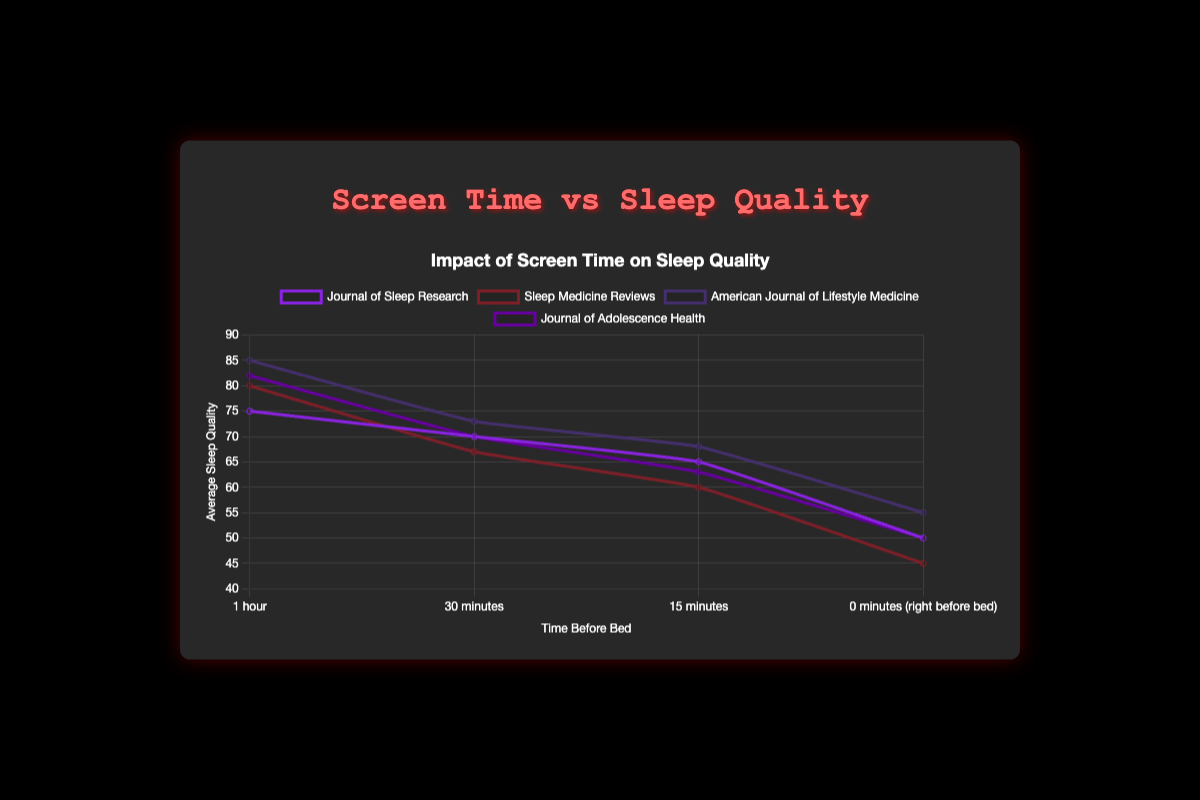What is the general trend of sleep quality as screen time increases right before bed? By looking at the data, we notice a negative trend where sleep quality decreases as screen time increases right before bed. Specifically, from 1 hour to 0 minutes (right before bed), the sleep quality generally declines.
Answer: Sleep quality decreases Which dataset shows the highest average sleep quality for screen time of 1 hour before bed? Looking at the line chart, "American Journal of Lifestyle Medicine" shows the highest average sleep quality for screen time of 1 hour before bed, which is 85.
Answer: American Journal of Lifestyle Medicine Compare the sleep quality for screen time at "15 minutes" and "0 minutes (right before bed)" in the "Journal of Adolescence Health" dataset. For the "Journal of Adolescence Health" dataset, the sleep quality is 63 at "15 minutes" and 50 at "0 minutes (right before bed)". Thus, the sleep quality is higher at "15 minutes" before bed.
Answer: 63 vs. 50 By how much does the sleep quality decrease on average when comparing screen time of 1 hour to “0 minutes (right before bed)” across all sources? For each source, calcualte the decrease in sleep quality: Journal of Sleep Research (75 - 50 = 25%), Sleep Medicine Reviews (80 - 45 = 35%), American Journal of Lifestyle Medicine (85 - 55 = 30%), Journal of Adolescence Health (82 - 50 = 32%). Averaging these: (25% + 35% + 30% + 32%)/4 = 30.5%.
Answer: 30.5% Which color line represents the "Sleep Medicine Reviews" average sleep quality? In the chart, each dataset is represented by a different color line. To identify "Sleep Medicine Reviews", we must reference the legend.
Answer: Varies by generated color but identifiable by legend label "Sleep Medicine Reviews" Is the impact on sleep quality more severe when the screen time is "15 minutes" or "30 minutes" before bed on average? By comparing the sleep quality between "15 minutes" and "30 minutes" before bed across all sources: Journal of Sleep Research (65 vs 70), Sleep Medicine Reviews (60 vs 67), American Journal of Lifestyle Medicine (68 vs 73), Journal of Adolescence Health (63 vs 70). We see that the drop in sleep quality is more significant at "15 minutes" before bed than 30 minutes.
Answer: More severe at 15 minutes 